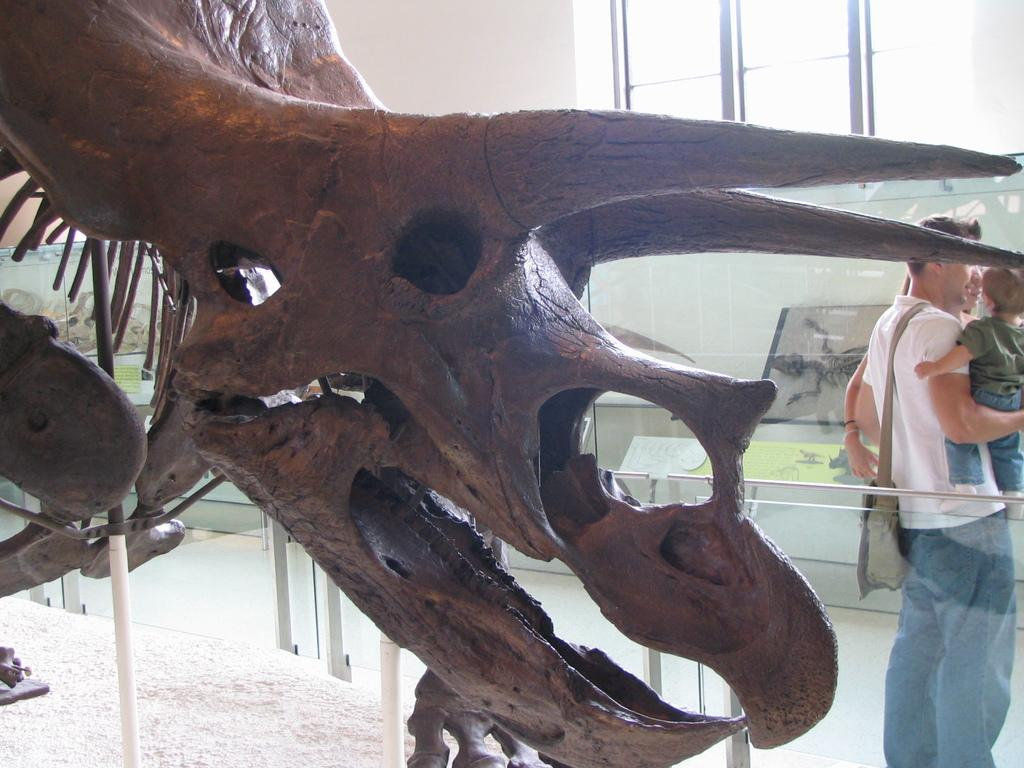What is the main subject of the image? The main subject of the image is a dragon skeleton. What objects can be seen in the image besides the dragon skeleton? There are glasses visible in the image. Can you describe the people in the image? There are persons in the image. What can be seen in the background of the image? There is a wall, windows, and boards in the background of the image. What type of headwear is the bird wearing in the image? There is no bird present in the image, so it is not possible to determine what type of headwear it might be wearing. 